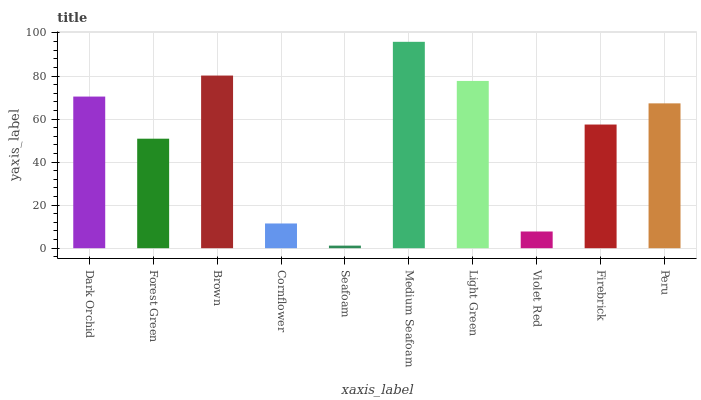Is Seafoam the minimum?
Answer yes or no. Yes. Is Medium Seafoam the maximum?
Answer yes or no. Yes. Is Forest Green the minimum?
Answer yes or no. No. Is Forest Green the maximum?
Answer yes or no. No. Is Dark Orchid greater than Forest Green?
Answer yes or no. Yes. Is Forest Green less than Dark Orchid?
Answer yes or no. Yes. Is Forest Green greater than Dark Orchid?
Answer yes or no. No. Is Dark Orchid less than Forest Green?
Answer yes or no. No. Is Peru the high median?
Answer yes or no. Yes. Is Firebrick the low median?
Answer yes or no. Yes. Is Violet Red the high median?
Answer yes or no. No. Is Cornflower the low median?
Answer yes or no. No. 